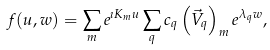<formula> <loc_0><loc_0><loc_500><loc_500>f ( u , w ) = \sum _ { m } e ^ { \imath K _ { m } u } \sum _ { q } c _ { q } \left ( \vec { V } _ { q } \right ) _ { m } e ^ { \lambda _ { q } w } ,</formula> 